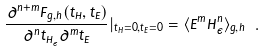Convert formula to latex. <formula><loc_0><loc_0><loc_500><loc_500>\frac { \partial ^ { n + m } F _ { g , h } ( t _ { H } , t _ { E } ) } { \partial ^ { n } t _ { H _ { \epsilon } } \partial ^ { m } t _ { E } } | _ { t _ { H } = 0 , t _ { E } = 0 } = \langle E ^ { m } H _ { \epsilon } ^ { n } \rangle _ { g , h } \ .</formula> 